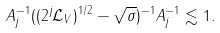<formula> <loc_0><loc_0><loc_500><loc_500>\| A _ { j } ^ { - 1 } ( ( 2 ^ { j } \mathcal { L } _ { V } ) ^ { 1 / 2 } - \sqrt { \sigma } ) ^ { - 1 } A _ { j } ^ { - 1 } \| \lesssim 1 .</formula> 